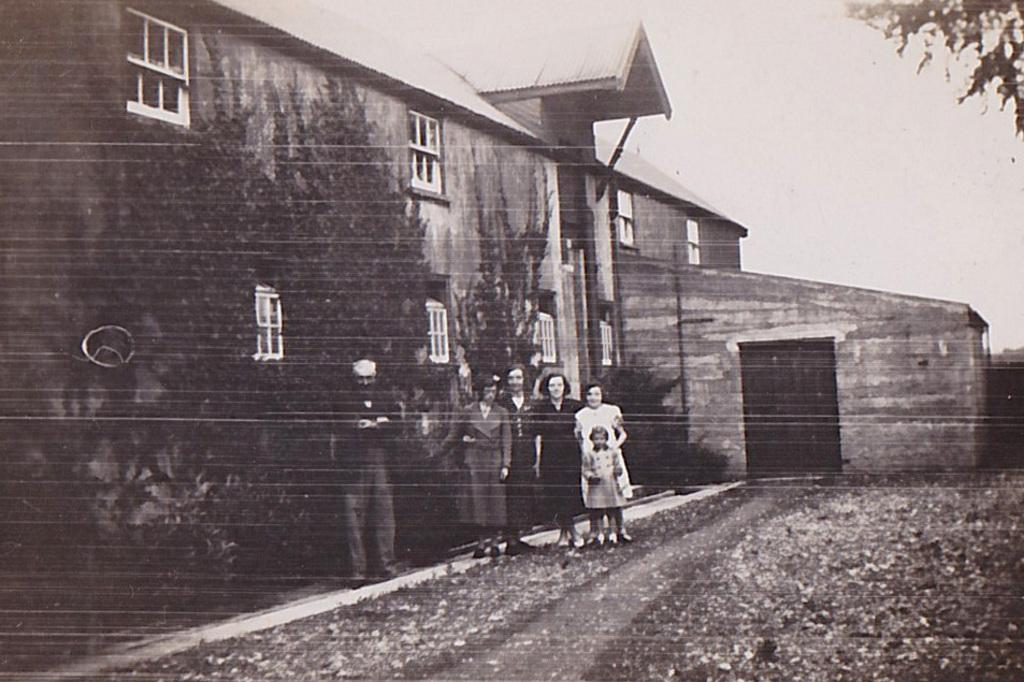How many people are present in the image? There is a man, four women, and a kid in the image, making a total of six people. What are the people doing in the image? The people are standing in front of a house and looking at someone. Can you describe the setting of the image? The people are standing in front of a house, which suggests they might be outside. What type of straw is being offered to the kid in the image? There is no straw present in the image, and therefore no such offering can be observed. 